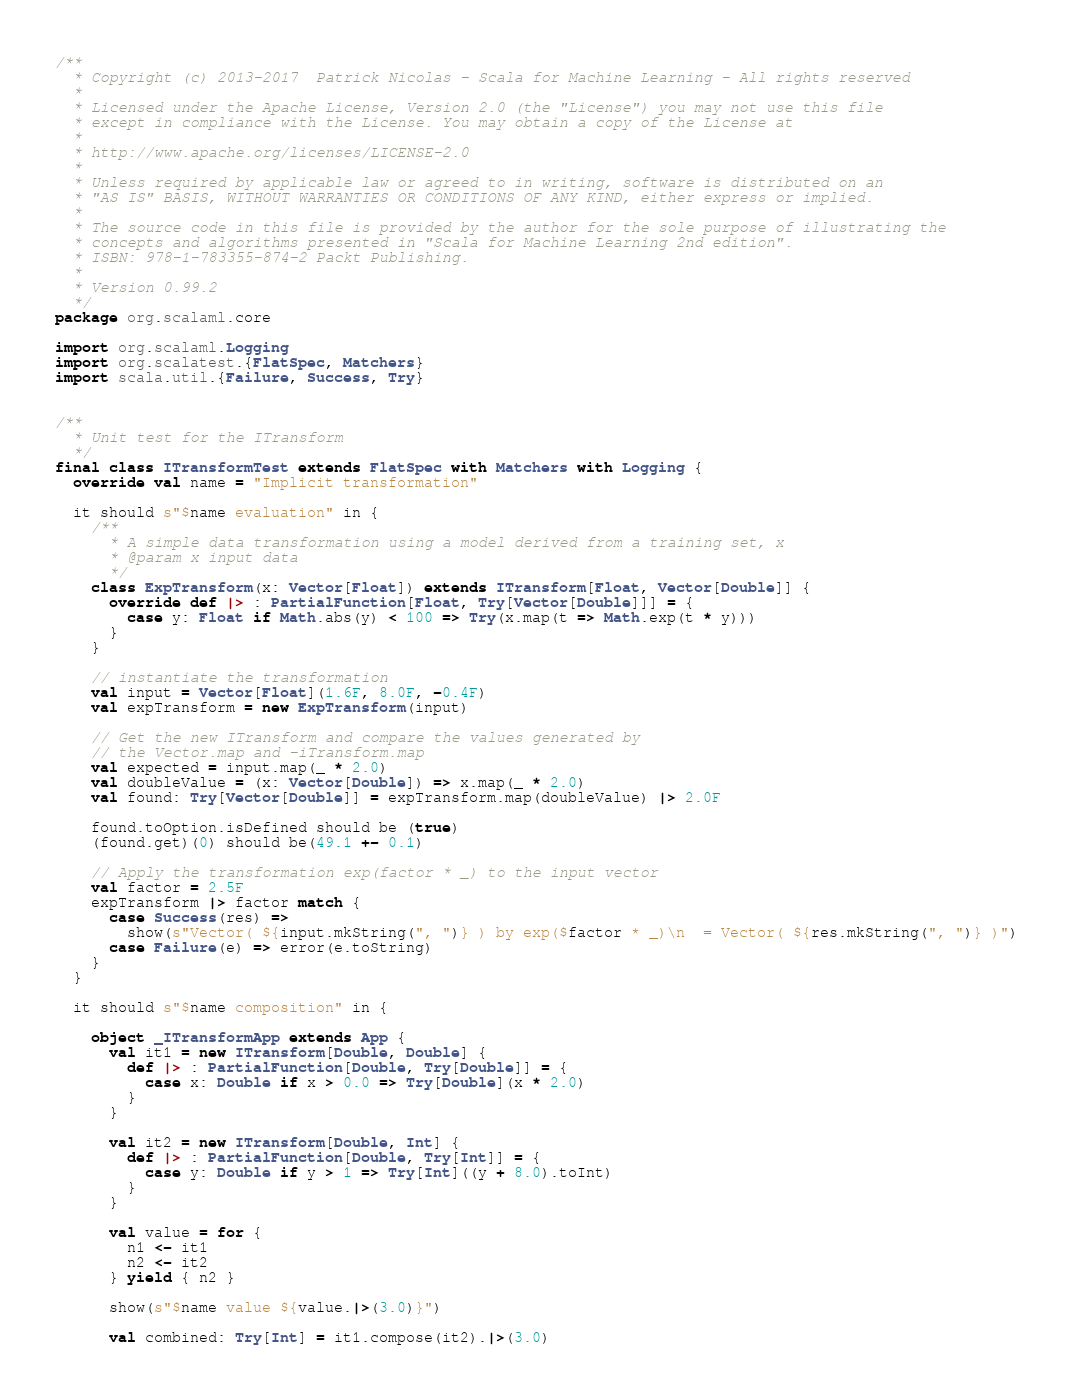<code> <loc_0><loc_0><loc_500><loc_500><_Scala_>/**
  * Copyright (c) 2013-2017  Patrick Nicolas - Scala for Machine Learning - All rights reserved
  *
  * Licensed under the Apache License, Version 2.0 (the "License") you may not use this file
  * except in compliance with the License. You may obtain a copy of the License at
  *
  * http://www.apache.org/licenses/LICENSE-2.0
  *
  * Unless required by applicable law or agreed to in writing, software is distributed on an
  * "AS IS" BASIS, WITHOUT WARRANTIES OR CONDITIONS OF ANY KIND, either express or implied.
  *
  * The source code in this file is provided by the author for the sole purpose of illustrating the
  * concepts and algorithms presented in "Scala for Machine Learning 2nd edition".
  * ISBN: 978-1-783355-874-2 Packt Publishing.
  *
  * Version 0.99.2
  */
package org.scalaml.core

import org.scalaml.Logging
import org.scalatest.{FlatSpec, Matchers}
import scala.util.{Failure, Success, Try}


/**
  * Unit test for the ITransform
  */
final class ITransformTest extends FlatSpec with Matchers with Logging {
  override val name = "Implicit transformation"

  it should s"$name evaluation" in {
    /**
      * A simple data transformation using a model derived from a training set, x
      * @param x input data
      */
    class ExpTransform(x: Vector[Float]) extends ITransform[Float, Vector[Double]] {
      override def |> : PartialFunction[Float, Try[Vector[Double]]] = {
        case y: Float if Math.abs(y) < 100 => Try(x.map(t => Math.exp(t * y)))
      }
    }

    // instantiate the transformation
    val input = Vector[Float](1.6F, 8.0F, -0.4F)
    val expTransform = new ExpTransform(input)

    // Get the new ITransform and compare the values generated by
    // the Vector.map and -iTransform.map
    val expected = input.map(_ * 2.0)
    val doubleValue = (x: Vector[Double]) => x.map(_ * 2.0)
    val found: Try[Vector[Double]] = expTransform.map(doubleValue) |> 2.0F

    found.toOption.isDefined should be (true)
    (found.get)(0) should be(49.1 +- 0.1)

    // Apply the transformation exp(factor * _) to the input vector
    val factor = 2.5F
    expTransform |> factor match {
      case Success(res) =>
        show(s"Vector( ${input.mkString(", ")} ) by exp($factor * _)\n  = Vector( ${res.mkString(", ")} )")
      case Failure(e) => error(e.toString)
    }
  }

  it should s"$name composition" in {

    object _ITransformApp extends App {
      val it1 = new ITransform[Double, Double] {
        def |> : PartialFunction[Double, Try[Double]] = {
          case x: Double if x > 0.0 => Try[Double](x * 2.0)
        }
      }

      val it2 = new ITransform[Double, Int] {
        def |> : PartialFunction[Double, Try[Int]] = {
          case y: Double if y > 1 => Try[Int]((y + 8.0).toInt)
        }
      }

      val value = for {
        n1 <- it1
        n2 <- it2
      } yield { n2 }

      show(s"$name value ${value.|>(3.0)}")

      val combined: Try[Int] = it1.compose(it2).|>(3.0)</code> 